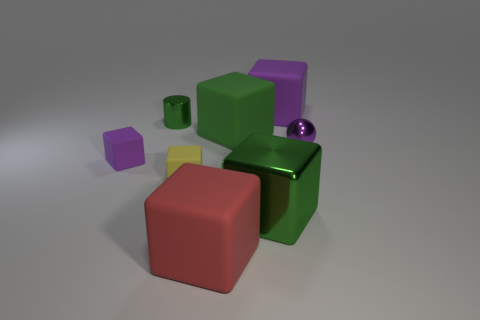Subtract 4 blocks. How many blocks are left? 2 Subtract all large red matte blocks. How many blocks are left? 5 Subtract all red cubes. How many cubes are left? 5 Subtract all yellow blocks. Subtract all green balls. How many blocks are left? 5 Add 2 large red things. How many objects exist? 10 Subtract all cubes. How many objects are left? 2 Add 1 tiny metallic objects. How many tiny metallic objects exist? 3 Subtract 1 red cubes. How many objects are left? 7 Subtract all yellow cubes. Subtract all green metallic objects. How many objects are left? 5 Add 7 big green rubber blocks. How many big green rubber blocks are left? 8 